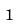Convert formula to latex. <formula><loc_0><loc_0><loc_500><loc_500>1</formula> 